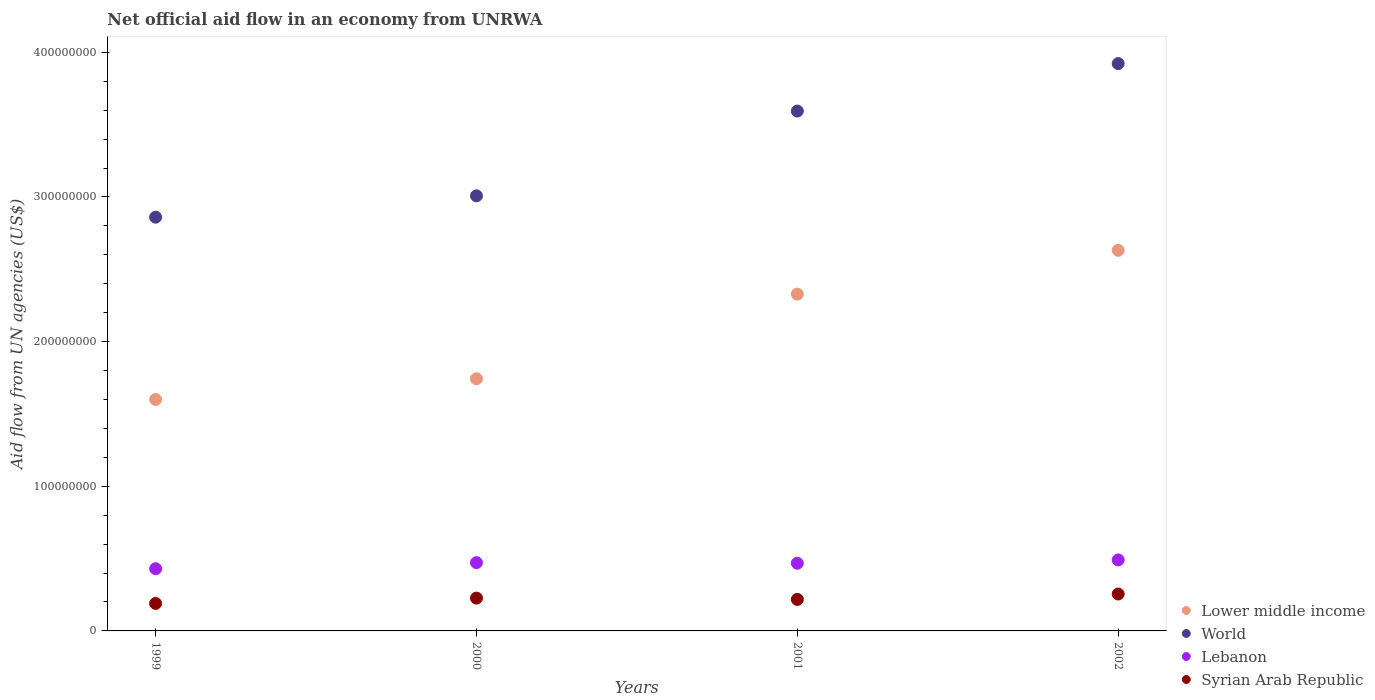How many different coloured dotlines are there?
Provide a short and direct response. 4. Is the number of dotlines equal to the number of legend labels?
Your response must be concise. Yes. What is the net official aid flow in World in 2000?
Keep it short and to the point. 3.01e+08. Across all years, what is the maximum net official aid flow in Lebanon?
Offer a terse response. 4.91e+07. Across all years, what is the minimum net official aid flow in Lower middle income?
Your answer should be compact. 1.60e+08. In which year was the net official aid flow in World maximum?
Your answer should be compact. 2002. In which year was the net official aid flow in Lower middle income minimum?
Provide a succinct answer. 1999. What is the total net official aid flow in Syrian Arab Republic in the graph?
Give a very brief answer. 8.90e+07. What is the difference between the net official aid flow in Lebanon in 2000 and that in 2002?
Your answer should be very brief. -1.88e+06. What is the difference between the net official aid flow in Lebanon in 1999 and the net official aid flow in Syrian Arab Republic in 2001?
Provide a succinct answer. 2.12e+07. What is the average net official aid flow in Lower middle income per year?
Your answer should be compact. 2.08e+08. In the year 2000, what is the difference between the net official aid flow in Lower middle income and net official aid flow in Syrian Arab Republic?
Provide a short and direct response. 1.52e+08. In how many years, is the net official aid flow in Lebanon greater than 140000000 US$?
Make the answer very short. 0. What is the ratio of the net official aid flow in Lower middle income in 2001 to that in 2002?
Give a very brief answer. 0.88. What is the difference between the highest and the second highest net official aid flow in World?
Offer a very short reply. 3.28e+07. What is the difference between the highest and the lowest net official aid flow in World?
Offer a very short reply. 1.06e+08. Is it the case that in every year, the sum of the net official aid flow in World and net official aid flow in Lebanon  is greater than the net official aid flow in Syrian Arab Republic?
Your answer should be very brief. Yes. Does the net official aid flow in Lower middle income monotonically increase over the years?
Your response must be concise. Yes. How many dotlines are there?
Your response must be concise. 4. What is the difference between two consecutive major ticks on the Y-axis?
Offer a very short reply. 1.00e+08. Are the values on the major ticks of Y-axis written in scientific E-notation?
Make the answer very short. No. Does the graph contain any zero values?
Offer a very short reply. No. Where does the legend appear in the graph?
Your response must be concise. Bottom right. What is the title of the graph?
Your answer should be very brief. Net official aid flow in an economy from UNRWA. What is the label or title of the X-axis?
Provide a succinct answer. Years. What is the label or title of the Y-axis?
Keep it short and to the point. Aid flow from UN agencies (US$). What is the Aid flow from UN agencies (US$) in Lower middle income in 1999?
Provide a short and direct response. 1.60e+08. What is the Aid flow from UN agencies (US$) of World in 1999?
Provide a succinct answer. 2.86e+08. What is the Aid flow from UN agencies (US$) in Lebanon in 1999?
Keep it short and to the point. 4.30e+07. What is the Aid flow from UN agencies (US$) of Syrian Arab Republic in 1999?
Offer a very short reply. 1.90e+07. What is the Aid flow from UN agencies (US$) in Lower middle income in 2000?
Keep it short and to the point. 1.74e+08. What is the Aid flow from UN agencies (US$) of World in 2000?
Provide a succinct answer. 3.01e+08. What is the Aid flow from UN agencies (US$) of Lebanon in 2000?
Provide a short and direct response. 4.72e+07. What is the Aid flow from UN agencies (US$) of Syrian Arab Republic in 2000?
Your answer should be compact. 2.27e+07. What is the Aid flow from UN agencies (US$) in Lower middle income in 2001?
Give a very brief answer. 2.33e+08. What is the Aid flow from UN agencies (US$) of World in 2001?
Your answer should be compact. 3.59e+08. What is the Aid flow from UN agencies (US$) of Lebanon in 2001?
Your response must be concise. 4.68e+07. What is the Aid flow from UN agencies (US$) in Syrian Arab Republic in 2001?
Give a very brief answer. 2.18e+07. What is the Aid flow from UN agencies (US$) in Lower middle income in 2002?
Offer a very short reply. 2.63e+08. What is the Aid flow from UN agencies (US$) in World in 2002?
Offer a very short reply. 3.92e+08. What is the Aid flow from UN agencies (US$) of Lebanon in 2002?
Keep it short and to the point. 4.91e+07. What is the Aid flow from UN agencies (US$) in Syrian Arab Republic in 2002?
Your response must be concise. 2.55e+07. Across all years, what is the maximum Aid flow from UN agencies (US$) in Lower middle income?
Offer a very short reply. 2.63e+08. Across all years, what is the maximum Aid flow from UN agencies (US$) in World?
Your answer should be compact. 3.92e+08. Across all years, what is the maximum Aid flow from UN agencies (US$) in Lebanon?
Your response must be concise. 4.91e+07. Across all years, what is the maximum Aid flow from UN agencies (US$) of Syrian Arab Republic?
Give a very brief answer. 2.55e+07. Across all years, what is the minimum Aid flow from UN agencies (US$) of Lower middle income?
Keep it short and to the point. 1.60e+08. Across all years, what is the minimum Aid flow from UN agencies (US$) in World?
Keep it short and to the point. 2.86e+08. Across all years, what is the minimum Aid flow from UN agencies (US$) in Lebanon?
Keep it short and to the point. 4.30e+07. Across all years, what is the minimum Aid flow from UN agencies (US$) of Syrian Arab Republic?
Ensure brevity in your answer.  1.90e+07. What is the total Aid flow from UN agencies (US$) of Lower middle income in the graph?
Provide a succinct answer. 8.30e+08. What is the total Aid flow from UN agencies (US$) in World in the graph?
Offer a very short reply. 1.34e+09. What is the total Aid flow from UN agencies (US$) of Lebanon in the graph?
Provide a succinct answer. 1.86e+08. What is the total Aid flow from UN agencies (US$) of Syrian Arab Republic in the graph?
Your answer should be compact. 8.90e+07. What is the difference between the Aid flow from UN agencies (US$) of Lower middle income in 1999 and that in 2000?
Your answer should be compact. -1.43e+07. What is the difference between the Aid flow from UN agencies (US$) in World in 1999 and that in 2000?
Provide a short and direct response. -1.48e+07. What is the difference between the Aid flow from UN agencies (US$) of Lebanon in 1999 and that in 2000?
Offer a very short reply. -4.21e+06. What is the difference between the Aid flow from UN agencies (US$) of Syrian Arab Republic in 1999 and that in 2000?
Offer a terse response. -3.68e+06. What is the difference between the Aid flow from UN agencies (US$) of Lower middle income in 1999 and that in 2001?
Make the answer very short. -7.28e+07. What is the difference between the Aid flow from UN agencies (US$) in World in 1999 and that in 2001?
Your response must be concise. -7.34e+07. What is the difference between the Aid flow from UN agencies (US$) in Lebanon in 1999 and that in 2001?
Provide a short and direct response. -3.79e+06. What is the difference between the Aid flow from UN agencies (US$) of Syrian Arab Republic in 1999 and that in 2001?
Your answer should be compact. -2.78e+06. What is the difference between the Aid flow from UN agencies (US$) of Lower middle income in 1999 and that in 2002?
Offer a terse response. -1.03e+08. What is the difference between the Aid flow from UN agencies (US$) of World in 1999 and that in 2002?
Your answer should be compact. -1.06e+08. What is the difference between the Aid flow from UN agencies (US$) of Lebanon in 1999 and that in 2002?
Offer a very short reply. -6.09e+06. What is the difference between the Aid flow from UN agencies (US$) in Syrian Arab Republic in 1999 and that in 2002?
Provide a succinct answer. -6.53e+06. What is the difference between the Aid flow from UN agencies (US$) in Lower middle income in 2000 and that in 2001?
Offer a terse response. -5.85e+07. What is the difference between the Aid flow from UN agencies (US$) in World in 2000 and that in 2001?
Give a very brief answer. -5.86e+07. What is the difference between the Aid flow from UN agencies (US$) in Lebanon in 2000 and that in 2001?
Make the answer very short. 4.20e+05. What is the difference between the Aid flow from UN agencies (US$) of Syrian Arab Republic in 2000 and that in 2001?
Keep it short and to the point. 9.00e+05. What is the difference between the Aid flow from UN agencies (US$) of Lower middle income in 2000 and that in 2002?
Offer a very short reply. -8.88e+07. What is the difference between the Aid flow from UN agencies (US$) of World in 2000 and that in 2002?
Your response must be concise. -9.14e+07. What is the difference between the Aid flow from UN agencies (US$) of Lebanon in 2000 and that in 2002?
Keep it short and to the point. -1.88e+06. What is the difference between the Aid flow from UN agencies (US$) of Syrian Arab Republic in 2000 and that in 2002?
Your answer should be very brief. -2.85e+06. What is the difference between the Aid flow from UN agencies (US$) in Lower middle income in 2001 and that in 2002?
Ensure brevity in your answer.  -3.03e+07. What is the difference between the Aid flow from UN agencies (US$) in World in 2001 and that in 2002?
Your answer should be very brief. -3.28e+07. What is the difference between the Aid flow from UN agencies (US$) in Lebanon in 2001 and that in 2002?
Provide a succinct answer. -2.30e+06. What is the difference between the Aid flow from UN agencies (US$) of Syrian Arab Republic in 2001 and that in 2002?
Offer a terse response. -3.75e+06. What is the difference between the Aid flow from UN agencies (US$) in Lower middle income in 1999 and the Aid flow from UN agencies (US$) in World in 2000?
Your answer should be very brief. -1.41e+08. What is the difference between the Aid flow from UN agencies (US$) of Lower middle income in 1999 and the Aid flow from UN agencies (US$) of Lebanon in 2000?
Make the answer very short. 1.13e+08. What is the difference between the Aid flow from UN agencies (US$) in Lower middle income in 1999 and the Aid flow from UN agencies (US$) in Syrian Arab Republic in 2000?
Provide a short and direct response. 1.37e+08. What is the difference between the Aid flow from UN agencies (US$) of World in 1999 and the Aid flow from UN agencies (US$) of Lebanon in 2000?
Ensure brevity in your answer.  2.39e+08. What is the difference between the Aid flow from UN agencies (US$) of World in 1999 and the Aid flow from UN agencies (US$) of Syrian Arab Republic in 2000?
Your response must be concise. 2.63e+08. What is the difference between the Aid flow from UN agencies (US$) in Lebanon in 1999 and the Aid flow from UN agencies (US$) in Syrian Arab Republic in 2000?
Ensure brevity in your answer.  2.03e+07. What is the difference between the Aid flow from UN agencies (US$) in Lower middle income in 1999 and the Aid flow from UN agencies (US$) in World in 2001?
Offer a very short reply. -1.99e+08. What is the difference between the Aid flow from UN agencies (US$) of Lower middle income in 1999 and the Aid flow from UN agencies (US$) of Lebanon in 2001?
Your answer should be compact. 1.13e+08. What is the difference between the Aid flow from UN agencies (US$) of Lower middle income in 1999 and the Aid flow from UN agencies (US$) of Syrian Arab Republic in 2001?
Keep it short and to the point. 1.38e+08. What is the difference between the Aid flow from UN agencies (US$) of World in 1999 and the Aid flow from UN agencies (US$) of Lebanon in 2001?
Provide a succinct answer. 2.39e+08. What is the difference between the Aid flow from UN agencies (US$) of World in 1999 and the Aid flow from UN agencies (US$) of Syrian Arab Republic in 2001?
Provide a succinct answer. 2.64e+08. What is the difference between the Aid flow from UN agencies (US$) in Lebanon in 1999 and the Aid flow from UN agencies (US$) in Syrian Arab Republic in 2001?
Your response must be concise. 2.12e+07. What is the difference between the Aid flow from UN agencies (US$) of Lower middle income in 1999 and the Aid flow from UN agencies (US$) of World in 2002?
Offer a terse response. -2.32e+08. What is the difference between the Aid flow from UN agencies (US$) of Lower middle income in 1999 and the Aid flow from UN agencies (US$) of Lebanon in 2002?
Offer a very short reply. 1.11e+08. What is the difference between the Aid flow from UN agencies (US$) of Lower middle income in 1999 and the Aid flow from UN agencies (US$) of Syrian Arab Republic in 2002?
Your answer should be compact. 1.34e+08. What is the difference between the Aid flow from UN agencies (US$) in World in 1999 and the Aid flow from UN agencies (US$) in Lebanon in 2002?
Provide a short and direct response. 2.37e+08. What is the difference between the Aid flow from UN agencies (US$) in World in 1999 and the Aid flow from UN agencies (US$) in Syrian Arab Republic in 2002?
Ensure brevity in your answer.  2.60e+08. What is the difference between the Aid flow from UN agencies (US$) of Lebanon in 1999 and the Aid flow from UN agencies (US$) of Syrian Arab Republic in 2002?
Provide a short and direct response. 1.75e+07. What is the difference between the Aid flow from UN agencies (US$) of Lower middle income in 2000 and the Aid flow from UN agencies (US$) of World in 2001?
Provide a short and direct response. -1.85e+08. What is the difference between the Aid flow from UN agencies (US$) of Lower middle income in 2000 and the Aid flow from UN agencies (US$) of Lebanon in 2001?
Ensure brevity in your answer.  1.28e+08. What is the difference between the Aid flow from UN agencies (US$) of Lower middle income in 2000 and the Aid flow from UN agencies (US$) of Syrian Arab Republic in 2001?
Give a very brief answer. 1.53e+08. What is the difference between the Aid flow from UN agencies (US$) of World in 2000 and the Aid flow from UN agencies (US$) of Lebanon in 2001?
Keep it short and to the point. 2.54e+08. What is the difference between the Aid flow from UN agencies (US$) of World in 2000 and the Aid flow from UN agencies (US$) of Syrian Arab Republic in 2001?
Your answer should be very brief. 2.79e+08. What is the difference between the Aid flow from UN agencies (US$) of Lebanon in 2000 and the Aid flow from UN agencies (US$) of Syrian Arab Republic in 2001?
Provide a short and direct response. 2.54e+07. What is the difference between the Aid flow from UN agencies (US$) in Lower middle income in 2000 and the Aid flow from UN agencies (US$) in World in 2002?
Your response must be concise. -2.18e+08. What is the difference between the Aid flow from UN agencies (US$) in Lower middle income in 2000 and the Aid flow from UN agencies (US$) in Lebanon in 2002?
Offer a very short reply. 1.25e+08. What is the difference between the Aid flow from UN agencies (US$) in Lower middle income in 2000 and the Aid flow from UN agencies (US$) in Syrian Arab Republic in 2002?
Give a very brief answer. 1.49e+08. What is the difference between the Aid flow from UN agencies (US$) in World in 2000 and the Aid flow from UN agencies (US$) in Lebanon in 2002?
Provide a succinct answer. 2.52e+08. What is the difference between the Aid flow from UN agencies (US$) in World in 2000 and the Aid flow from UN agencies (US$) in Syrian Arab Republic in 2002?
Provide a short and direct response. 2.75e+08. What is the difference between the Aid flow from UN agencies (US$) in Lebanon in 2000 and the Aid flow from UN agencies (US$) in Syrian Arab Republic in 2002?
Offer a terse response. 2.17e+07. What is the difference between the Aid flow from UN agencies (US$) of Lower middle income in 2001 and the Aid flow from UN agencies (US$) of World in 2002?
Offer a very short reply. -1.59e+08. What is the difference between the Aid flow from UN agencies (US$) of Lower middle income in 2001 and the Aid flow from UN agencies (US$) of Lebanon in 2002?
Your response must be concise. 1.84e+08. What is the difference between the Aid flow from UN agencies (US$) in Lower middle income in 2001 and the Aid flow from UN agencies (US$) in Syrian Arab Republic in 2002?
Make the answer very short. 2.07e+08. What is the difference between the Aid flow from UN agencies (US$) in World in 2001 and the Aid flow from UN agencies (US$) in Lebanon in 2002?
Offer a terse response. 3.10e+08. What is the difference between the Aid flow from UN agencies (US$) of World in 2001 and the Aid flow from UN agencies (US$) of Syrian Arab Republic in 2002?
Your answer should be compact. 3.34e+08. What is the difference between the Aid flow from UN agencies (US$) in Lebanon in 2001 and the Aid flow from UN agencies (US$) in Syrian Arab Republic in 2002?
Keep it short and to the point. 2.13e+07. What is the average Aid flow from UN agencies (US$) of Lower middle income per year?
Your answer should be compact. 2.08e+08. What is the average Aid flow from UN agencies (US$) of World per year?
Offer a terse response. 3.35e+08. What is the average Aid flow from UN agencies (US$) of Lebanon per year?
Your response must be concise. 4.65e+07. What is the average Aid flow from UN agencies (US$) of Syrian Arab Republic per year?
Ensure brevity in your answer.  2.22e+07. In the year 1999, what is the difference between the Aid flow from UN agencies (US$) in Lower middle income and Aid flow from UN agencies (US$) in World?
Give a very brief answer. -1.26e+08. In the year 1999, what is the difference between the Aid flow from UN agencies (US$) in Lower middle income and Aid flow from UN agencies (US$) in Lebanon?
Offer a very short reply. 1.17e+08. In the year 1999, what is the difference between the Aid flow from UN agencies (US$) in Lower middle income and Aid flow from UN agencies (US$) in Syrian Arab Republic?
Keep it short and to the point. 1.41e+08. In the year 1999, what is the difference between the Aid flow from UN agencies (US$) in World and Aid flow from UN agencies (US$) in Lebanon?
Provide a short and direct response. 2.43e+08. In the year 1999, what is the difference between the Aid flow from UN agencies (US$) in World and Aid flow from UN agencies (US$) in Syrian Arab Republic?
Give a very brief answer. 2.67e+08. In the year 1999, what is the difference between the Aid flow from UN agencies (US$) of Lebanon and Aid flow from UN agencies (US$) of Syrian Arab Republic?
Provide a short and direct response. 2.40e+07. In the year 2000, what is the difference between the Aid flow from UN agencies (US$) in Lower middle income and Aid flow from UN agencies (US$) in World?
Your response must be concise. -1.26e+08. In the year 2000, what is the difference between the Aid flow from UN agencies (US$) in Lower middle income and Aid flow from UN agencies (US$) in Lebanon?
Give a very brief answer. 1.27e+08. In the year 2000, what is the difference between the Aid flow from UN agencies (US$) of Lower middle income and Aid flow from UN agencies (US$) of Syrian Arab Republic?
Keep it short and to the point. 1.52e+08. In the year 2000, what is the difference between the Aid flow from UN agencies (US$) of World and Aid flow from UN agencies (US$) of Lebanon?
Keep it short and to the point. 2.54e+08. In the year 2000, what is the difference between the Aid flow from UN agencies (US$) in World and Aid flow from UN agencies (US$) in Syrian Arab Republic?
Keep it short and to the point. 2.78e+08. In the year 2000, what is the difference between the Aid flow from UN agencies (US$) in Lebanon and Aid flow from UN agencies (US$) in Syrian Arab Republic?
Offer a very short reply. 2.45e+07. In the year 2001, what is the difference between the Aid flow from UN agencies (US$) in Lower middle income and Aid flow from UN agencies (US$) in World?
Keep it short and to the point. -1.27e+08. In the year 2001, what is the difference between the Aid flow from UN agencies (US$) in Lower middle income and Aid flow from UN agencies (US$) in Lebanon?
Give a very brief answer. 1.86e+08. In the year 2001, what is the difference between the Aid flow from UN agencies (US$) of Lower middle income and Aid flow from UN agencies (US$) of Syrian Arab Republic?
Provide a short and direct response. 2.11e+08. In the year 2001, what is the difference between the Aid flow from UN agencies (US$) of World and Aid flow from UN agencies (US$) of Lebanon?
Your response must be concise. 3.13e+08. In the year 2001, what is the difference between the Aid flow from UN agencies (US$) of World and Aid flow from UN agencies (US$) of Syrian Arab Republic?
Your answer should be very brief. 3.38e+08. In the year 2001, what is the difference between the Aid flow from UN agencies (US$) in Lebanon and Aid flow from UN agencies (US$) in Syrian Arab Republic?
Your response must be concise. 2.50e+07. In the year 2002, what is the difference between the Aid flow from UN agencies (US$) of Lower middle income and Aid flow from UN agencies (US$) of World?
Keep it short and to the point. -1.29e+08. In the year 2002, what is the difference between the Aid flow from UN agencies (US$) of Lower middle income and Aid flow from UN agencies (US$) of Lebanon?
Ensure brevity in your answer.  2.14e+08. In the year 2002, what is the difference between the Aid flow from UN agencies (US$) in Lower middle income and Aid flow from UN agencies (US$) in Syrian Arab Republic?
Ensure brevity in your answer.  2.38e+08. In the year 2002, what is the difference between the Aid flow from UN agencies (US$) of World and Aid flow from UN agencies (US$) of Lebanon?
Make the answer very short. 3.43e+08. In the year 2002, what is the difference between the Aid flow from UN agencies (US$) of World and Aid flow from UN agencies (US$) of Syrian Arab Republic?
Keep it short and to the point. 3.67e+08. In the year 2002, what is the difference between the Aid flow from UN agencies (US$) in Lebanon and Aid flow from UN agencies (US$) in Syrian Arab Republic?
Make the answer very short. 2.36e+07. What is the ratio of the Aid flow from UN agencies (US$) in Lower middle income in 1999 to that in 2000?
Offer a terse response. 0.92. What is the ratio of the Aid flow from UN agencies (US$) in World in 1999 to that in 2000?
Give a very brief answer. 0.95. What is the ratio of the Aid flow from UN agencies (US$) in Lebanon in 1999 to that in 2000?
Your answer should be compact. 0.91. What is the ratio of the Aid flow from UN agencies (US$) in Syrian Arab Republic in 1999 to that in 2000?
Make the answer very short. 0.84. What is the ratio of the Aid flow from UN agencies (US$) in Lower middle income in 1999 to that in 2001?
Make the answer very short. 0.69. What is the ratio of the Aid flow from UN agencies (US$) in World in 1999 to that in 2001?
Offer a very short reply. 0.8. What is the ratio of the Aid flow from UN agencies (US$) in Lebanon in 1999 to that in 2001?
Make the answer very short. 0.92. What is the ratio of the Aid flow from UN agencies (US$) of Syrian Arab Republic in 1999 to that in 2001?
Your response must be concise. 0.87. What is the ratio of the Aid flow from UN agencies (US$) of Lower middle income in 1999 to that in 2002?
Your answer should be very brief. 0.61. What is the ratio of the Aid flow from UN agencies (US$) of World in 1999 to that in 2002?
Keep it short and to the point. 0.73. What is the ratio of the Aid flow from UN agencies (US$) in Lebanon in 1999 to that in 2002?
Ensure brevity in your answer.  0.88. What is the ratio of the Aid flow from UN agencies (US$) in Syrian Arab Republic in 1999 to that in 2002?
Offer a terse response. 0.74. What is the ratio of the Aid flow from UN agencies (US$) of Lower middle income in 2000 to that in 2001?
Offer a terse response. 0.75. What is the ratio of the Aid flow from UN agencies (US$) in World in 2000 to that in 2001?
Your answer should be very brief. 0.84. What is the ratio of the Aid flow from UN agencies (US$) of Lebanon in 2000 to that in 2001?
Offer a terse response. 1.01. What is the ratio of the Aid flow from UN agencies (US$) of Syrian Arab Republic in 2000 to that in 2001?
Offer a very short reply. 1.04. What is the ratio of the Aid flow from UN agencies (US$) in Lower middle income in 2000 to that in 2002?
Your answer should be very brief. 0.66. What is the ratio of the Aid flow from UN agencies (US$) of World in 2000 to that in 2002?
Your response must be concise. 0.77. What is the ratio of the Aid flow from UN agencies (US$) of Lebanon in 2000 to that in 2002?
Offer a terse response. 0.96. What is the ratio of the Aid flow from UN agencies (US$) of Syrian Arab Republic in 2000 to that in 2002?
Ensure brevity in your answer.  0.89. What is the ratio of the Aid flow from UN agencies (US$) in Lower middle income in 2001 to that in 2002?
Provide a short and direct response. 0.88. What is the ratio of the Aid flow from UN agencies (US$) in World in 2001 to that in 2002?
Give a very brief answer. 0.92. What is the ratio of the Aid flow from UN agencies (US$) of Lebanon in 2001 to that in 2002?
Your answer should be very brief. 0.95. What is the ratio of the Aid flow from UN agencies (US$) in Syrian Arab Republic in 2001 to that in 2002?
Provide a succinct answer. 0.85. What is the difference between the highest and the second highest Aid flow from UN agencies (US$) in Lower middle income?
Your answer should be compact. 3.03e+07. What is the difference between the highest and the second highest Aid flow from UN agencies (US$) in World?
Ensure brevity in your answer.  3.28e+07. What is the difference between the highest and the second highest Aid flow from UN agencies (US$) of Lebanon?
Your answer should be very brief. 1.88e+06. What is the difference between the highest and the second highest Aid flow from UN agencies (US$) in Syrian Arab Republic?
Provide a succinct answer. 2.85e+06. What is the difference between the highest and the lowest Aid flow from UN agencies (US$) of Lower middle income?
Make the answer very short. 1.03e+08. What is the difference between the highest and the lowest Aid flow from UN agencies (US$) in World?
Offer a terse response. 1.06e+08. What is the difference between the highest and the lowest Aid flow from UN agencies (US$) of Lebanon?
Offer a terse response. 6.09e+06. What is the difference between the highest and the lowest Aid flow from UN agencies (US$) in Syrian Arab Republic?
Your answer should be very brief. 6.53e+06. 